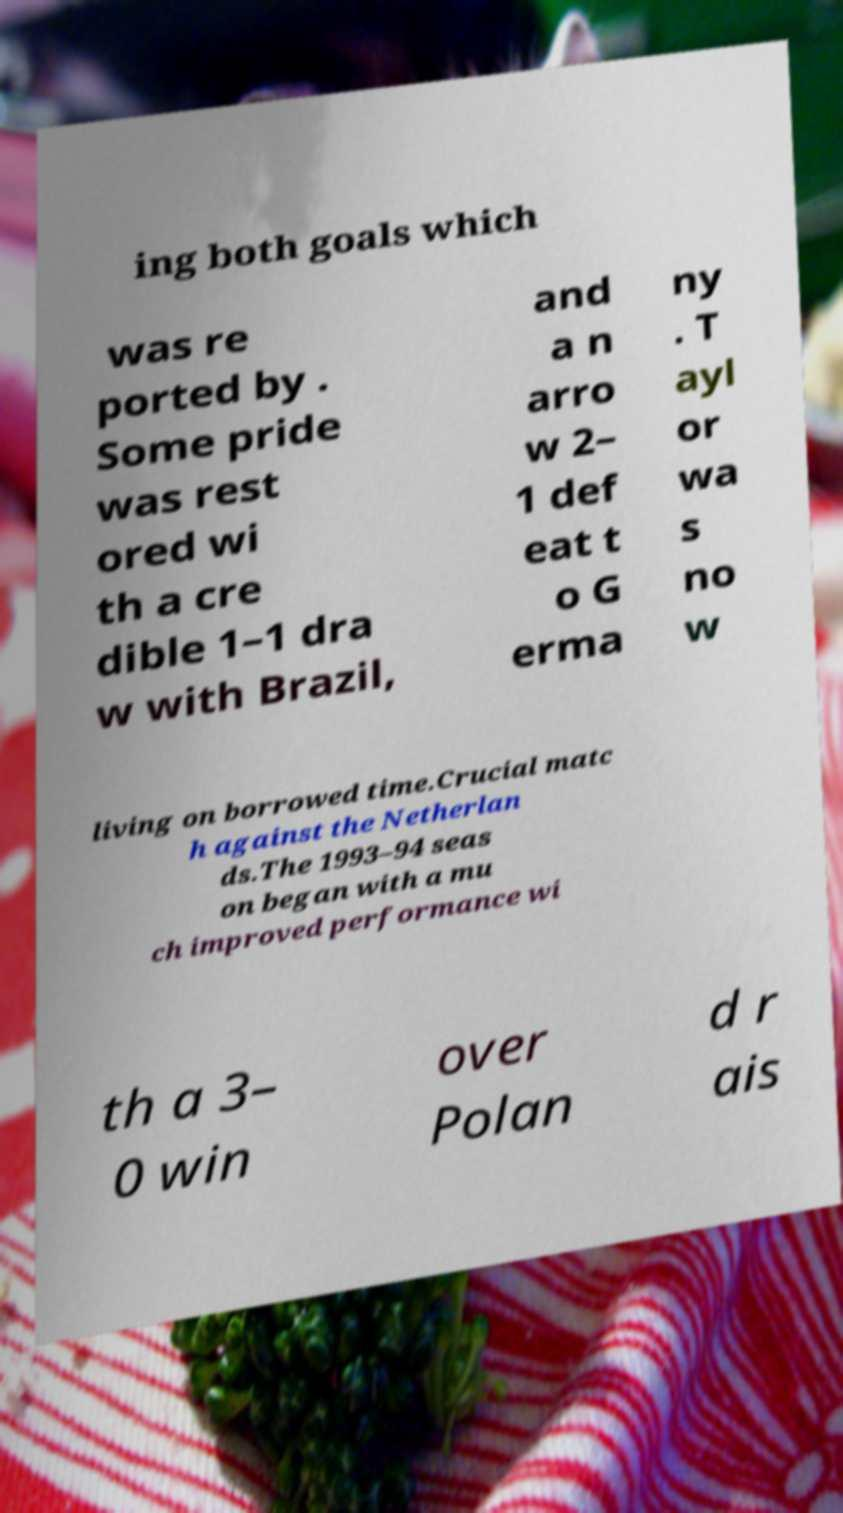Can you accurately transcribe the text from the provided image for me? ing both goals which was re ported by . Some pride was rest ored wi th a cre dible 1–1 dra w with Brazil, and a n arro w 2– 1 def eat t o G erma ny . T ayl or wa s no w living on borrowed time.Crucial matc h against the Netherlan ds.The 1993–94 seas on began with a mu ch improved performance wi th a 3– 0 win over Polan d r ais 